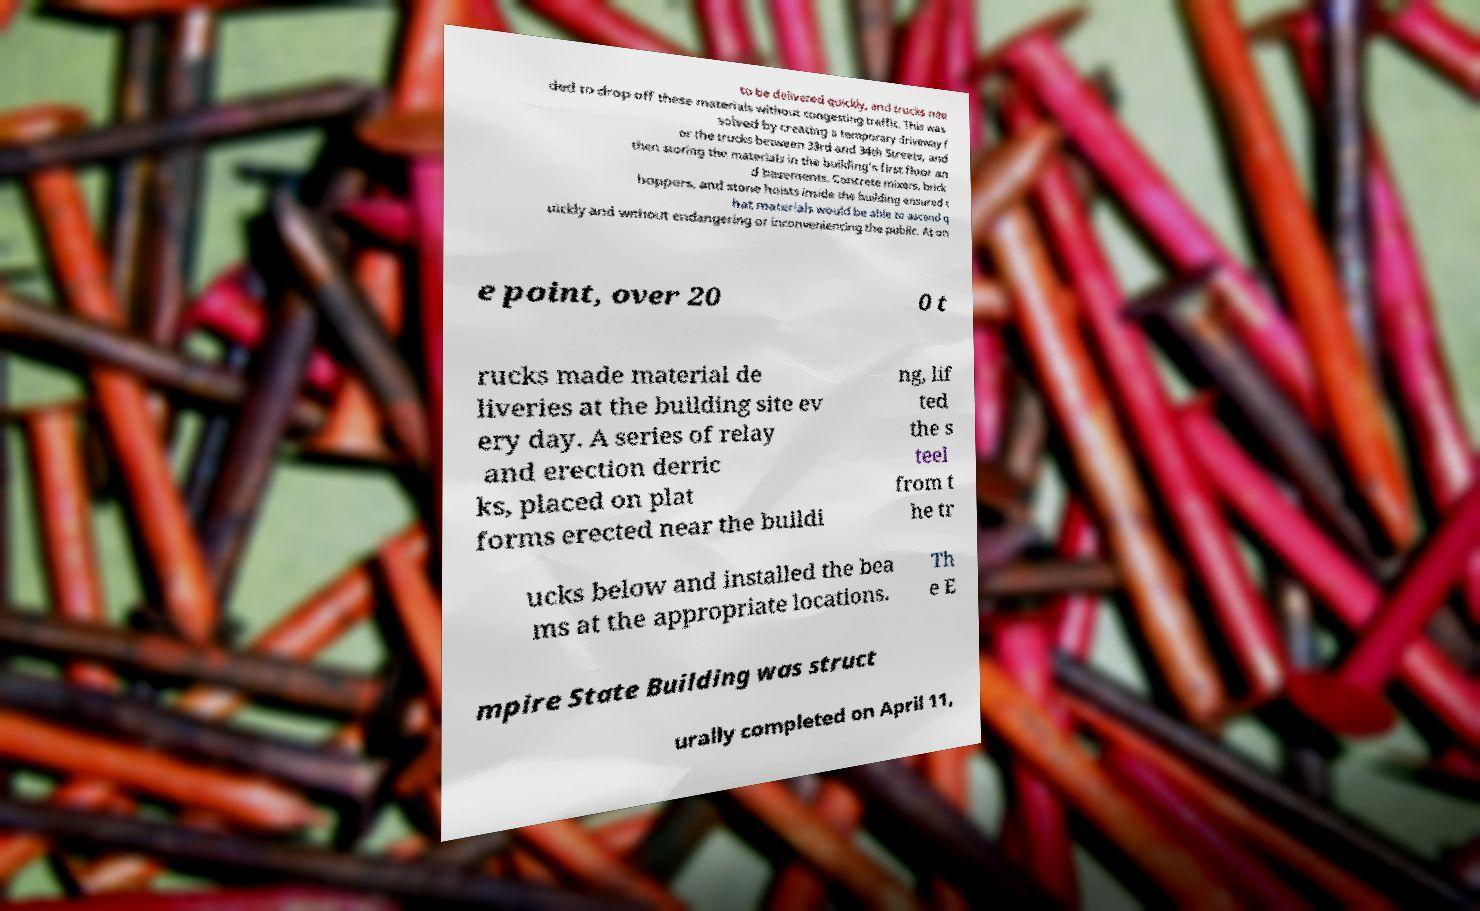For documentation purposes, I need the text within this image transcribed. Could you provide that? to be delivered quickly, and trucks nee ded to drop off these materials without congesting traffic. This was solved by creating a temporary driveway f or the trucks between 33rd and 34th Streets, and then storing the materials in the building's first floor an d basements. Concrete mixers, brick hoppers, and stone hoists inside the building ensured t hat materials would be able to ascend q uickly and without endangering or inconveniencing the public. At on e point, over 20 0 t rucks made material de liveries at the building site ev ery day. A series of relay and erection derric ks, placed on plat forms erected near the buildi ng, lif ted the s teel from t he tr ucks below and installed the bea ms at the appropriate locations. Th e E mpire State Building was struct urally completed on April 11, 